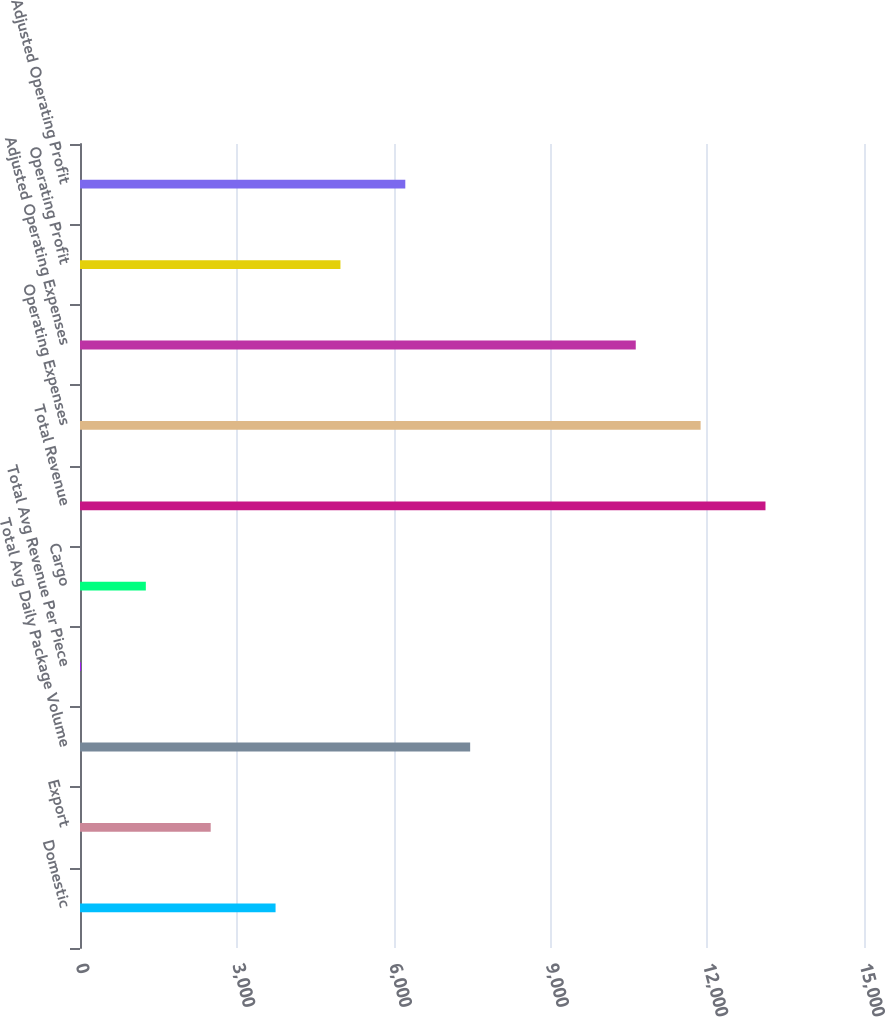<chart> <loc_0><loc_0><loc_500><loc_500><bar_chart><fcel>Domestic<fcel>Export<fcel>Total Avg Daily Package Volume<fcel>Total Avg Revenue Per Piece<fcel>Cargo<fcel>Total Revenue<fcel>Operating Expenses<fcel>Adjusted Operating Expenses<fcel>Operating Profit<fcel>Adjusted Operating Profit<nl><fcel>3741.69<fcel>2500.64<fcel>7464.84<fcel>18.54<fcel>1259.59<fcel>13115.1<fcel>11874<fcel>10633<fcel>4982.74<fcel>6223.79<nl></chart> 